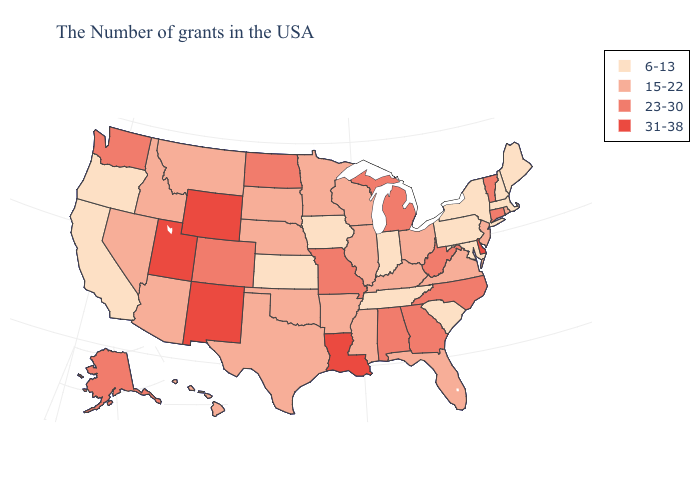Name the states that have a value in the range 23-30?
Write a very short answer. Vermont, Connecticut, North Carolina, West Virginia, Georgia, Michigan, Alabama, Missouri, North Dakota, Colorado, Washington, Alaska. Is the legend a continuous bar?
Concise answer only. No. Name the states that have a value in the range 31-38?
Answer briefly. Delaware, Louisiana, Wyoming, New Mexico, Utah. What is the highest value in the MidWest ?
Keep it brief. 23-30. What is the highest value in states that border North Carolina?
Quick response, please. 23-30. Which states hav the highest value in the MidWest?
Quick response, please. Michigan, Missouri, North Dakota. Does Maine have the lowest value in the USA?
Be succinct. Yes. What is the value of Arizona?
Give a very brief answer. 15-22. Among the states that border Minnesota , does South Dakota have the highest value?
Be succinct. No. What is the value of Maine?
Answer briefly. 6-13. Does the map have missing data?
Answer briefly. No. What is the value of Vermont?
Give a very brief answer. 23-30. What is the value of South Dakota?
Be succinct. 15-22. What is the highest value in the Northeast ?
Give a very brief answer. 23-30. What is the value of Florida?
Short answer required. 15-22. 